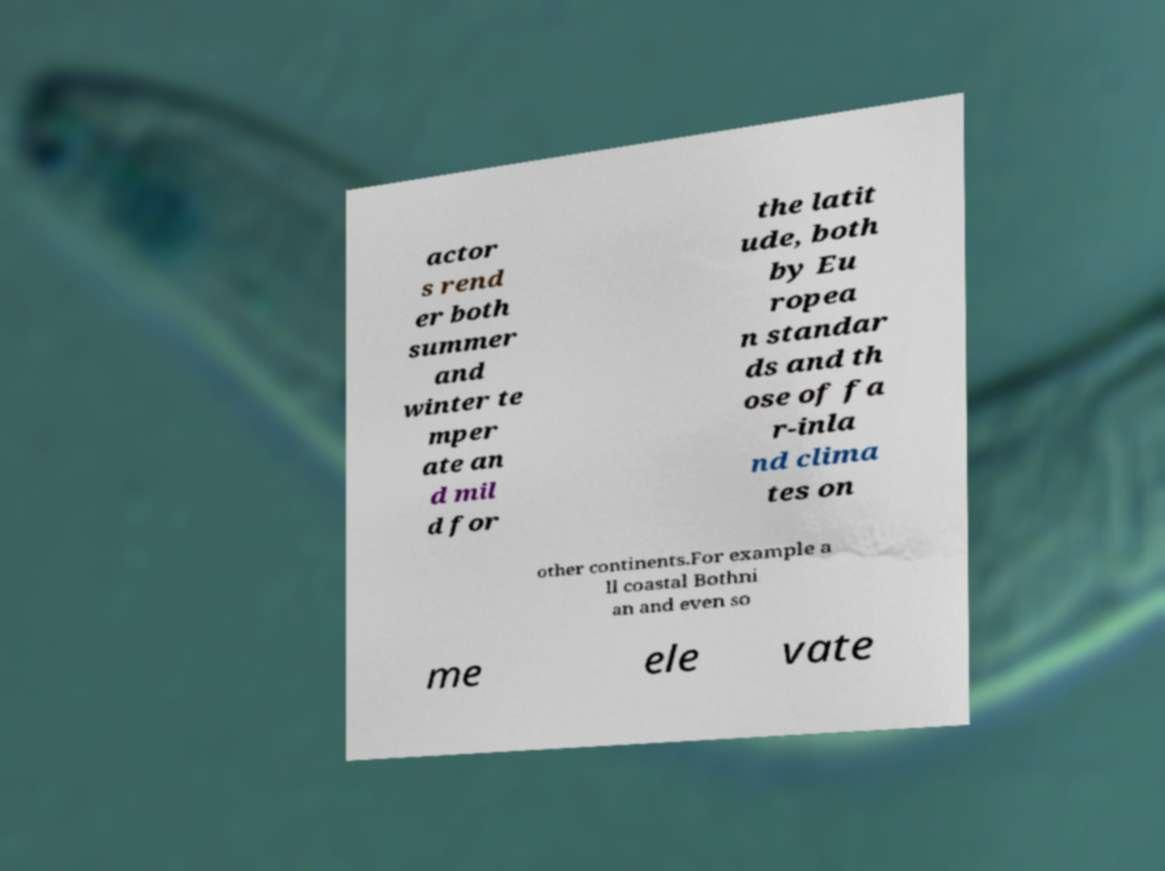For documentation purposes, I need the text within this image transcribed. Could you provide that? actor s rend er both summer and winter te mper ate an d mil d for the latit ude, both by Eu ropea n standar ds and th ose of fa r-inla nd clima tes on other continents.For example a ll coastal Bothni an and even so me ele vate 